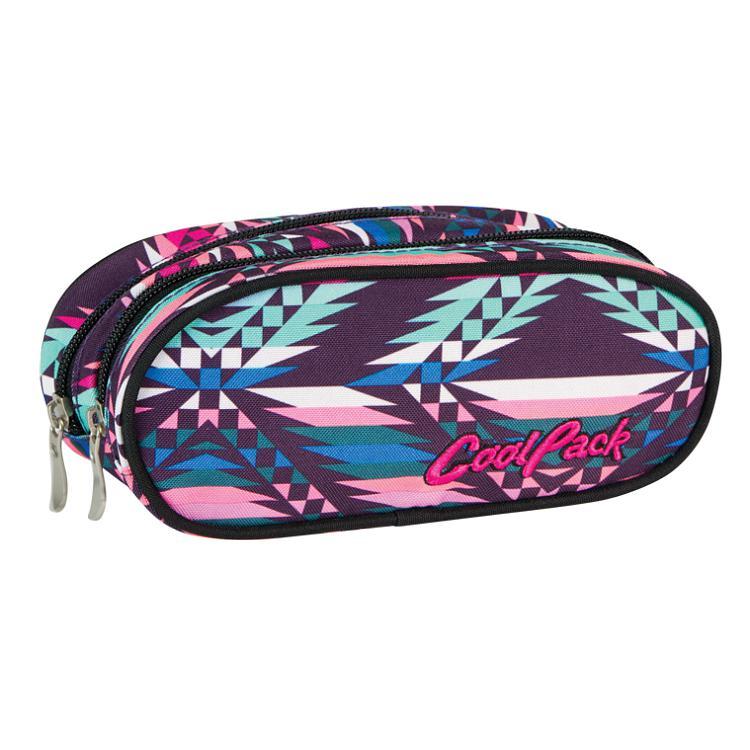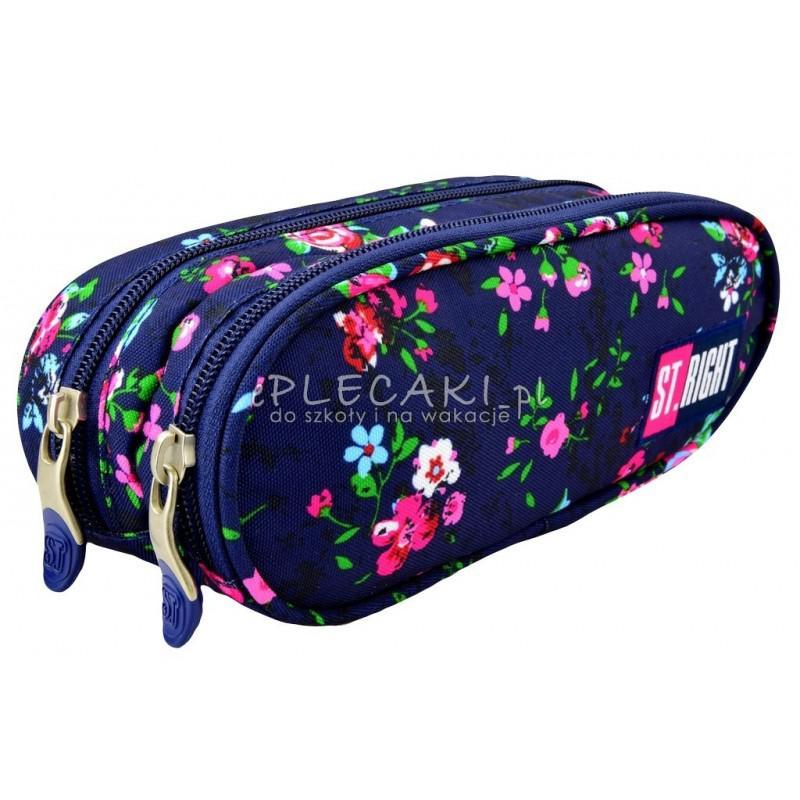The first image is the image on the left, the second image is the image on the right. Assess this claim about the two images: "There is a Monster High pencil case.". Correct or not? Answer yes or no. No. The first image is the image on the left, the second image is the image on the right. Evaluate the accuracy of this statement regarding the images: "in the image pair there are two oval shaped pencil pouches with cording on the outside". Is it true? Answer yes or no. Yes. 